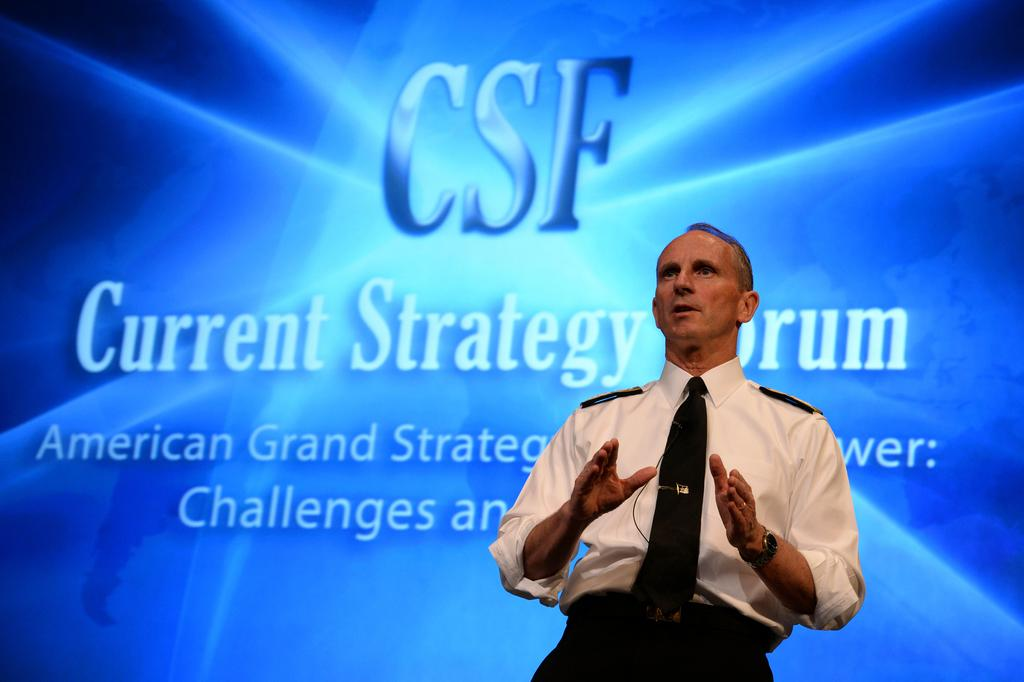What is the main subject of the image? There is a person standing in the image. What is the person wearing on their upper body? The person is wearing a white shirt and a tie. What can be seen in the background of the image? There is a blue screen in the background of the image. What type of rhythm does the person in the image have while riding the carriage? There is no carriage present in the image, and therefore no rhythm or riding can be observed. 